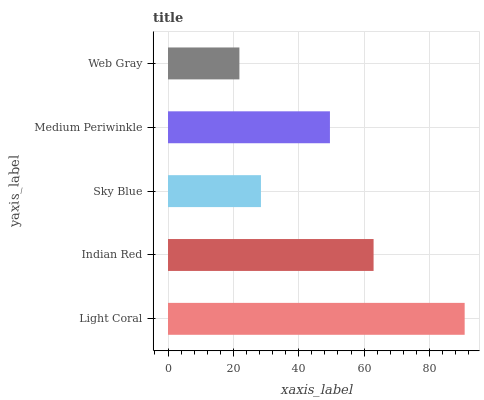Is Web Gray the minimum?
Answer yes or no. Yes. Is Light Coral the maximum?
Answer yes or no. Yes. Is Indian Red the minimum?
Answer yes or no. No. Is Indian Red the maximum?
Answer yes or no. No. Is Light Coral greater than Indian Red?
Answer yes or no. Yes. Is Indian Red less than Light Coral?
Answer yes or no. Yes. Is Indian Red greater than Light Coral?
Answer yes or no. No. Is Light Coral less than Indian Red?
Answer yes or no. No. Is Medium Periwinkle the high median?
Answer yes or no. Yes. Is Medium Periwinkle the low median?
Answer yes or no. Yes. Is Web Gray the high median?
Answer yes or no. No. Is Web Gray the low median?
Answer yes or no. No. 